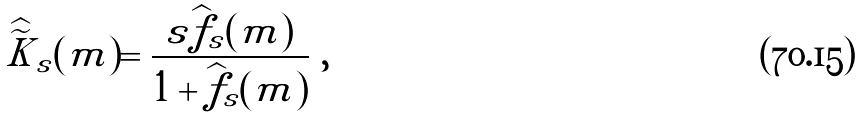<formula> <loc_0><loc_0><loc_500><loc_500>\widehat { \widetilde { K } } _ { s } ( m ) = \frac { s \widehat { f } _ { s } ( m ) } { 1 + \widehat { f } _ { s } ( m ) } \ ,</formula> 